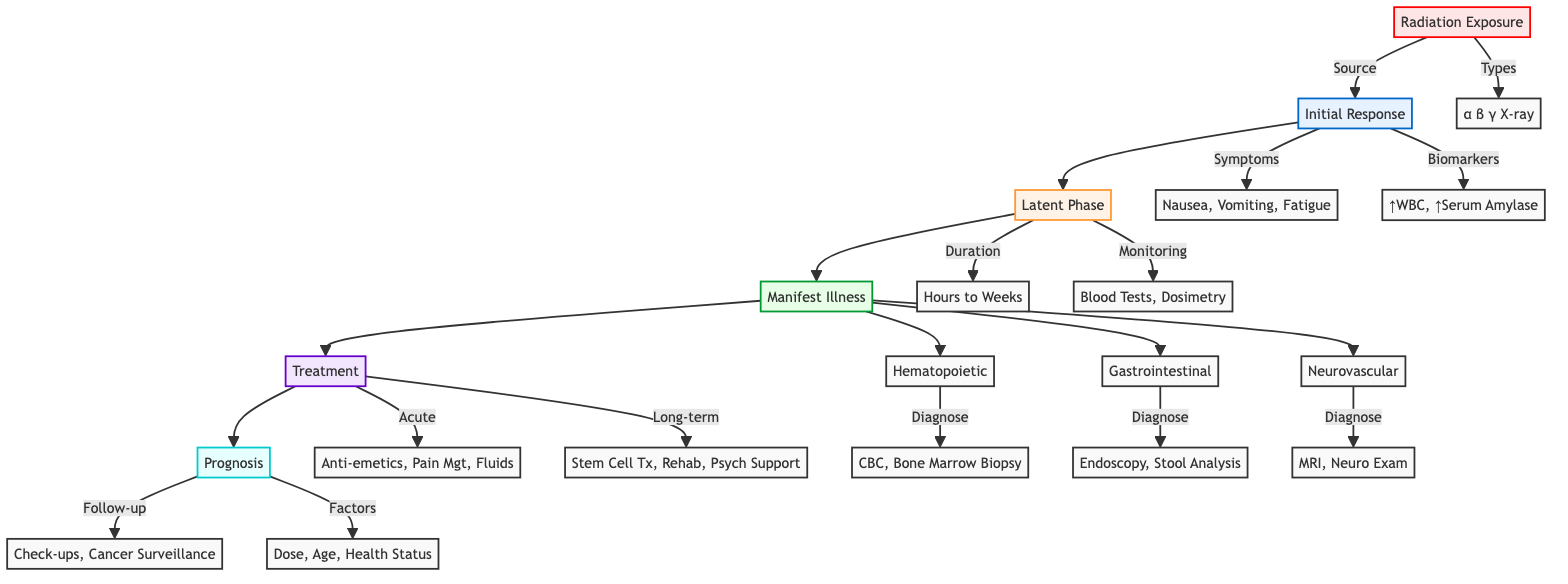What types of radiation are mentioned in the diagram? The diagram lists types of radiation under the "Radiation Exposure" node, which includes Alpha, Beta, Gamma, and X-ray.
Answer: Alpha, Beta, Gamma, X-ray What immediate symptoms are noted in the initial response? The "Initial Response" node identifies immediate symptoms as Nausea, Vomiting, and Fatigue.
Answer: Nausea, Vomiting, Fatigue How long is the symptom-free period during the latent phase? The "Latent Phase" node states the symptom-free period lasts from a few hours to a few weeks.
Answer: Few hours to few weeks Which condition requires a Complete Blood Count for diagnosis? The "Hematopoietic Syndrome" node indicates that a Complete Blood Count (CBC) is used for diagnosis.
Answer: Hematopoietic Syndrome What is the acute treatment mentioned in the pathway? Under the "Treatment" node, the acute management strategies listed include Anti-emetics, Pain Management, and Fluid Resuscitation.
Answer: Anti-emetics, Pain Management, Fluid Resuscitation How does the treatment follow after manifest illness? The arrows indicate that after "Manifest Illness," the pathway proceeds directly to "Treatment," including both acute and long-term care individually.
Answer: Treatment Which syndrome listed has GI bleeding as a symptom? The "Gastrointestinal Syndrome" node lists Severe Diarrhea, GI Bleeding, and Nutritional Malabsorption as symptoms.
Answer: Gastrointestinal Syndrome What factors are important for prognosis monitoring? The "Prognostic Factors" node mentions Total Radiation Dose, Patient Age, and Overall Health Status as critical aspects for prognosis.
Answer: Total Radiation Dose, Patient Age, Overall Health Status What type of examination is used for diagnosing Neurovascular Syndrome? According to the "Neurovascular Syndrome" node, diagnosis requires an MRI and a Neurological Examination.
Answer: MRI, Neurological Examination 